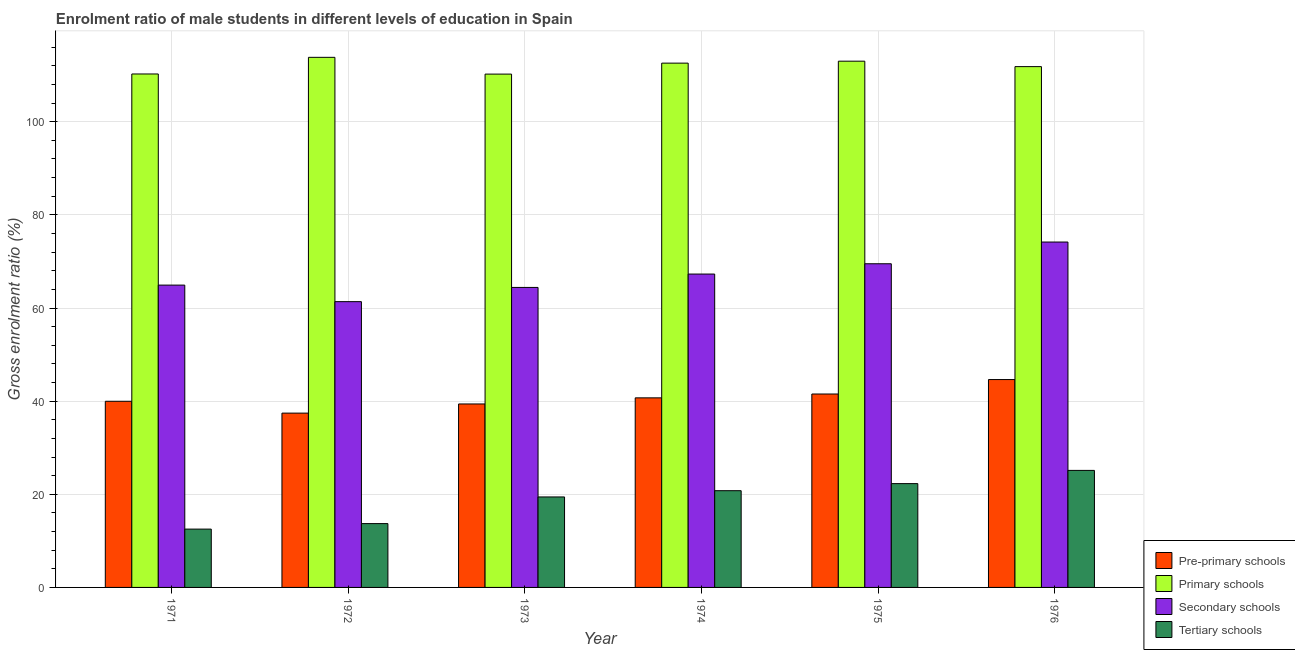How many groups of bars are there?
Offer a terse response. 6. Are the number of bars on each tick of the X-axis equal?
Your response must be concise. Yes. How many bars are there on the 3rd tick from the left?
Keep it short and to the point. 4. What is the label of the 6th group of bars from the left?
Provide a succinct answer. 1976. In how many cases, is the number of bars for a given year not equal to the number of legend labels?
Make the answer very short. 0. What is the gross enrolment ratio(female) in pre-primary schools in 1976?
Provide a short and direct response. 44.63. Across all years, what is the maximum gross enrolment ratio(female) in primary schools?
Your response must be concise. 113.83. Across all years, what is the minimum gross enrolment ratio(female) in pre-primary schools?
Your answer should be very brief. 37.43. What is the total gross enrolment ratio(female) in secondary schools in the graph?
Offer a very short reply. 401.65. What is the difference between the gross enrolment ratio(female) in pre-primary schools in 1972 and that in 1973?
Offer a terse response. -1.96. What is the difference between the gross enrolment ratio(female) in secondary schools in 1972 and the gross enrolment ratio(female) in primary schools in 1973?
Ensure brevity in your answer.  -3.05. What is the average gross enrolment ratio(female) in secondary schools per year?
Keep it short and to the point. 66.94. In how many years, is the gross enrolment ratio(female) in primary schools greater than 96 %?
Your answer should be very brief. 6. What is the ratio of the gross enrolment ratio(female) in pre-primary schools in 1971 to that in 1976?
Give a very brief answer. 0.9. Is the gross enrolment ratio(female) in secondary schools in 1974 less than that in 1975?
Offer a terse response. Yes. What is the difference between the highest and the second highest gross enrolment ratio(female) in pre-primary schools?
Ensure brevity in your answer.  3.1. What is the difference between the highest and the lowest gross enrolment ratio(female) in secondary schools?
Make the answer very short. 12.8. Is it the case that in every year, the sum of the gross enrolment ratio(female) in primary schools and gross enrolment ratio(female) in pre-primary schools is greater than the sum of gross enrolment ratio(female) in tertiary schools and gross enrolment ratio(female) in secondary schools?
Keep it short and to the point. Yes. What does the 3rd bar from the left in 1975 represents?
Your response must be concise. Secondary schools. What does the 3rd bar from the right in 1972 represents?
Offer a very short reply. Primary schools. Is it the case that in every year, the sum of the gross enrolment ratio(female) in pre-primary schools and gross enrolment ratio(female) in primary schools is greater than the gross enrolment ratio(female) in secondary schools?
Offer a very short reply. Yes. How many years are there in the graph?
Ensure brevity in your answer.  6. What is the difference between two consecutive major ticks on the Y-axis?
Provide a short and direct response. 20. Does the graph contain grids?
Make the answer very short. Yes. Where does the legend appear in the graph?
Offer a very short reply. Bottom right. How many legend labels are there?
Your answer should be compact. 4. How are the legend labels stacked?
Offer a terse response. Vertical. What is the title of the graph?
Provide a succinct answer. Enrolment ratio of male students in different levels of education in Spain. What is the label or title of the X-axis?
Give a very brief answer. Year. What is the label or title of the Y-axis?
Your answer should be compact. Gross enrolment ratio (%). What is the Gross enrolment ratio (%) of Pre-primary schools in 1971?
Your response must be concise. 39.97. What is the Gross enrolment ratio (%) of Primary schools in 1971?
Offer a very short reply. 110.25. What is the Gross enrolment ratio (%) in Secondary schools in 1971?
Your response must be concise. 64.92. What is the Gross enrolment ratio (%) of Tertiary schools in 1971?
Provide a succinct answer. 12.52. What is the Gross enrolment ratio (%) of Pre-primary schools in 1972?
Your answer should be compact. 37.43. What is the Gross enrolment ratio (%) in Primary schools in 1972?
Ensure brevity in your answer.  113.83. What is the Gross enrolment ratio (%) of Secondary schools in 1972?
Your answer should be very brief. 61.36. What is the Gross enrolment ratio (%) in Tertiary schools in 1972?
Offer a terse response. 13.71. What is the Gross enrolment ratio (%) in Pre-primary schools in 1973?
Give a very brief answer. 39.39. What is the Gross enrolment ratio (%) of Primary schools in 1973?
Provide a short and direct response. 110.23. What is the Gross enrolment ratio (%) in Secondary schools in 1973?
Provide a short and direct response. 64.42. What is the Gross enrolment ratio (%) of Tertiary schools in 1973?
Your answer should be very brief. 19.43. What is the Gross enrolment ratio (%) in Pre-primary schools in 1974?
Provide a short and direct response. 40.71. What is the Gross enrolment ratio (%) of Primary schools in 1974?
Your answer should be very brief. 112.58. What is the Gross enrolment ratio (%) of Secondary schools in 1974?
Ensure brevity in your answer.  67.29. What is the Gross enrolment ratio (%) of Tertiary schools in 1974?
Make the answer very short. 20.77. What is the Gross enrolment ratio (%) of Pre-primary schools in 1975?
Offer a very short reply. 41.53. What is the Gross enrolment ratio (%) of Primary schools in 1975?
Offer a very short reply. 113. What is the Gross enrolment ratio (%) in Secondary schools in 1975?
Ensure brevity in your answer.  69.5. What is the Gross enrolment ratio (%) of Tertiary schools in 1975?
Provide a succinct answer. 22.29. What is the Gross enrolment ratio (%) of Pre-primary schools in 1976?
Keep it short and to the point. 44.63. What is the Gross enrolment ratio (%) in Primary schools in 1976?
Provide a short and direct response. 111.83. What is the Gross enrolment ratio (%) of Secondary schools in 1976?
Provide a short and direct response. 74.17. What is the Gross enrolment ratio (%) in Tertiary schools in 1976?
Keep it short and to the point. 25.13. Across all years, what is the maximum Gross enrolment ratio (%) in Pre-primary schools?
Offer a very short reply. 44.63. Across all years, what is the maximum Gross enrolment ratio (%) in Primary schools?
Your response must be concise. 113.83. Across all years, what is the maximum Gross enrolment ratio (%) in Secondary schools?
Keep it short and to the point. 74.17. Across all years, what is the maximum Gross enrolment ratio (%) in Tertiary schools?
Offer a very short reply. 25.13. Across all years, what is the minimum Gross enrolment ratio (%) of Pre-primary schools?
Give a very brief answer. 37.43. Across all years, what is the minimum Gross enrolment ratio (%) of Primary schools?
Your answer should be very brief. 110.23. Across all years, what is the minimum Gross enrolment ratio (%) in Secondary schools?
Provide a succinct answer. 61.36. Across all years, what is the minimum Gross enrolment ratio (%) of Tertiary schools?
Provide a succinct answer. 12.52. What is the total Gross enrolment ratio (%) of Pre-primary schools in the graph?
Ensure brevity in your answer.  243.67. What is the total Gross enrolment ratio (%) of Primary schools in the graph?
Keep it short and to the point. 671.71. What is the total Gross enrolment ratio (%) in Secondary schools in the graph?
Your answer should be compact. 401.65. What is the total Gross enrolment ratio (%) of Tertiary schools in the graph?
Make the answer very short. 113.85. What is the difference between the Gross enrolment ratio (%) in Pre-primary schools in 1971 and that in 1972?
Offer a very short reply. 2.54. What is the difference between the Gross enrolment ratio (%) in Primary schools in 1971 and that in 1972?
Your answer should be compact. -3.58. What is the difference between the Gross enrolment ratio (%) in Secondary schools in 1971 and that in 1972?
Your answer should be compact. 3.55. What is the difference between the Gross enrolment ratio (%) in Tertiary schools in 1971 and that in 1972?
Provide a succinct answer. -1.18. What is the difference between the Gross enrolment ratio (%) in Pre-primary schools in 1971 and that in 1973?
Ensure brevity in your answer.  0.58. What is the difference between the Gross enrolment ratio (%) of Primary schools in 1971 and that in 1973?
Your answer should be compact. 0.03. What is the difference between the Gross enrolment ratio (%) in Secondary schools in 1971 and that in 1973?
Provide a short and direct response. 0.5. What is the difference between the Gross enrolment ratio (%) of Tertiary schools in 1971 and that in 1973?
Your answer should be very brief. -6.91. What is the difference between the Gross enrolment ratio (%) of Pre-primary schools in 1971 and that in 1974?
Offer a very short reply. -0.73. What is the difference between the Gross enrolment ratio (%) in Primary schools in 1971 and that in 1974?
Offer a very short reply. -2.33. What is the difference between the Gross enrolment ratio (%) in Secondary schools in 1971 and that in 1974?
Your answer should be very brief. -2.37. What is the difference between the Gross enrolment ratio (%) of Tertiary schools in 1971 and that in 1974?
Give a very brief answer. -8.25. What is the difference between the Gross enrolment ratio (%) in Pre-primary schools in 1971 and that in 1975?
Your answer should be compact. -1.56. What is the difference between the Gross enrolment ratio (%) in Primary schools in 1971 and that in 1975?
Your answer should be very brief. -2.75. What is the difference between the Gross enrolment ratio (%) of Secondary schools in 1971 and that in 1975?
Offer a very short reply. -4.58. What is the difference between the Gross enrolment ratio (%) in Tertiary schools in 1971 and that in 1975?
Your answer should be compact. -9.77. What is the difference between the Gross enrolment ratio (%) in Pre-primary schools in 1971 and that in 1976?
Offer a terse response. -4.66. What is the difference between the Gross enrolment ratio (%) of Primary schools in 1971 and that in 1976?
Your response must be concise. -1.58. What is the difference between the Gross enrolment ratio (%) of Secondary schools in 1971 and that in 1976?
Your answer should be compact. -9.25. What is the difference between the Gross enrolment ratio (%) of Tertiary schools in 1971 and that in 1976?
Keep it short and to the point. -12.61. What is the difference between the Gross enrolment ratio (%) in Pre-primary schools in 1972 and that in 1973?
Provide a short and direct response. -1.96. What is the difference between the Gross enrolment ratio (%) in Primary schools in 1972 and that in 1973?
Your response must be concise. 3.6. What is the difference between the Gross enrolment ratio (%) in Secondary schools in 1972 and that in 1973?
Give a very brief answer. -3.05. What is the difference between the Gross enrolment ratio (%) of Tertiary schools in 1972 and that in 1973?
Make the answer very short. -5.72. What is the difference between the Gross enrolment ratio (%) of Pre-primary schools in 1972 and that in 1974?
Your answer should be very brief. -3.28. What is the difference between the Gross enrolment ratio (%) of Primary schools in 1972 and that in 1974?
Provide a short and direct response. 1.25. What is the difference between the Gross enrolment ratio (%) in Secondary schools in 1972 and that in 1974?
Your response must be concise. -5.93. What is the difference between the Gross enrolment ratio (%) of Tertiary schools in 1972 and that in 1974?
Provide a short and direct response. -7.06. What is the difference between the Gross enrolment ratio (%) in Pre-primary schools in 1972 and that in 1975?
Keep it short and to the point. -4.1. What is the difference between the Gross enrolment ratio (%) in Primary schools in 1972 and that in 1975?
Ensure brevity in your answer.  0.83. What is the difference between the Gross enrolment ratio (%) of Secondary schools in 1972 and that in 1975?
Ensure brevity in your answer.  -8.13. What is the difference between the Gross enrolment ratio (%) of Tertiary schools in 1972 and that in 1975?
Your answer should be very brief. -8.58. What is the difference between the Gross enrolment ratio (%) of Pre-primary schools in 1972 and that in 1976?
Make the answer very short. -7.2. What is the difference between the Gross enrolment ratio (%) in Primary schools in 1972 and that in 1976?
Keep it short and to the point. 2. What is the difference between the Gross enrolment ratio (%) of Secondary schools in 1972 and that in 1976?
Give a very brief answer. -12.8. What is the difference between the Gross enrolment ratio (%) of Tertiary schools in 1972 and that in 1976?
Your answer should be very brief. -11.42. What is the difference between the Gross enrolment ratio (%) in Pre-primary schools in 1973 and that in 1974?
Keep it short and to the point. -1.31. What is the difference between the Gross enrolment ratio (%) of Primary schools in 1973 and that in 1974?
Provide a short and direct response. -2.35. What is the difference between the Gross enrolment ratio (%) in Secondary schools in 1973 and that in 1974?
Ensure brevity in your answer.  -2.87. What is the difference between the Gross enrolment ratio (%) of Tertiary schools in 1973 and that in 1974?
Ensure brevity in your answer.  -1.34. What is the difference between the Gross enrolment ratio (%) of Pre-primary schools in 1973 and that in 1975?
Keep it short and to the point. -2.14. What is the difference between the Gross enrolment ratio (%) in Primary schools in 1973 and that in 1975?
Your response must be concise. -2.77. What is the difference between the Gross enrolment ratio (%) of Secondary schools in 1973 and that in 1975?
Ensure brevity in your answer.  -5.08. What is the difference between the Gross enrolment ratio (%) of Tertiary schools in 1973 and that in 1975?
Offer a very short reply. -2.86. What is the difference between the Gross enrolment ratio (%) of Pre-primary schools in 1973 and that in 1976?
Your answer should be compact. -5.24. What is the difference between the Gross enrolment ratio (%) of Primary schools in 1973 and that in 1976?
Your answer should be very brief. -1.6. What is the difference between the Gross enrolment ratio (%) of Secondary schools in 1973 and that in 1976?
Your answer should be compact. -9.75. What is the difference between the Gross enrolment ratio (%) of Tertiary schools in 1973 and that in 1976?
Give a very brief answer. -5.7. What is the difference between the Gross enrolment ratio (%) of Pre-primary schools in 1974 and that in 1975?
Offer a very short reply. -0.82. What is the difference between the Gross enrolment ratio (%) in Primary schools in 1974 and that in 1975?
Provide a succinct answer. -0.42. What is the difference between the Gross enrolment ratio (%) of Secondary schools in 1974 and that in 1975?
Provide a short and direct response. -2.21. What is the difference between the Gross enrolment ratio (%) in Tertiary schools in 1974 and that in 1975?
Ensure brevity in your answer.  -1.52. What is the difference between the Gross enrolment ratio (%) in Pre-primary schools in 1974 and that in 1976?
Ensure brevity in your answer.  -3.93. What is the difference between the Gross enrolment ratio (%) in Primary schools in 1974 and that in 1976?
Your response must be concise. 0.75. What is the difference between the Gross enrolment ratio (%) of Secondary schools in 1974 and that in 1976?
Provide a short and direct response. -6.87. What is the difference between the Gross enrolment ratio (%) in Tertiary schools in 1974 and that in 1976?
Offer a very short reply. -4.36. What is the difference between the Gross enrolment ratio (%) of Pre-primary schools in 1975 and that in 1976?
Offer a very short reply. -3.1. What is the difference between the Gross enrolment ratio (%) of Primary schools in 1975 and that in 1976?
Make the answer very short. 1.17. What is the difference between the Gross enrolment ratio (%) of Secondary schools in 1975 and that in 1976?
Make the answer very short. -4.67. What is the difference between the Gross enrolment ratio (%) in Tertiary schools in 1975 and that in 1976?
Give a very brief answer. -2.84. What is the difference between the Gross enrolment ratio (%) in Pre-primary schools in 1971 and the Gross enrolment ratio (%) in Primary schools in 1972?
Provide a succinct answer. -73.85. What is the difference between the Gross enrolment ratio (%) of Pre-primary schools in 1971 and the Gross enrolment ratio (%) of Secondary schools in 1972?
Give a very brief answer. -21.39. What is the difference between the Gross enrolment ratio (%) in Pre-primary schools in 1971 and the Gross enrolment ratio (%) in Tertiary schools in 1972?
Ensure brevity in your answer.  26.27. What is the difference between the Gross enrolment ratio (%) in Primary schools in 1971 and the Gross enrolment ratio (%) in Secondary schools in 1972?
Give a very brief answer. 48.89. What is the difference between the Gross enrolment ratio (%) of Primary schools in 1971 and the Gross enrolment ratio (%) of Tertiary schools in 1972?
Offer a terse response. 96.54. What is the difference between the Gross enrolment ratio (%) of Secondary schools in 1971 and the Gross enrolment ratio (%) of Tertiary schools in 1972?
Your answer should be compact. 51.21. What is the difference between the Gross enrolment ratio (%) of Pre-primary schools in 1971 and the Gross enrolment ratio (%) of Primary schools in 1973?
Your answer should be compact. -70.25. What is the difference between the Gross enrolment ratio (%) in Pre-primary schools in 1971 and the Gross enrolment ratio (%) in Secondary schools in 1973?
Provide a succinct answer. -24.45. What is the difference between the Gross enrolment ratio (%) of Pre-primary schools in 1971 and the Gross enrolment ratio (%) of Tertiary schools in 1973?
Provide a succinct answer. 20.54. What is the difference between the Gross enrolment ratio (%) of Primary schools in 1971 and the Gross enrolment ratio (%) of Secondary schools in 1973?
Your response must be concise. 45.83. What is the difference between the Gross enrolment ratio (%) in Primary schools in 1971 and the Gross enrolment ratio (%) in Tertiary schools in 1973?
Make the answer very short. 90.82. What is the difference between the Gross enrolment ratio (%) in Secondary schools in 1971 and the Gross enrolment ratio (%) in Tertiary schools in 1973?
Offer a terse response. 45.49. What is the difference between the Gross enrolment ratio (%) of Pre-primary schools in 1971 and the Gross enrolment ratio (%) of Primary schools in 1974?
Provide a short and direct response. -72.61. What is the difference between the Gross enrolment ratio (%) in Pre-primary schools in 1971 and the Gross enrolment ratio (%) in Secondary schools in 1974?
Offer a very short reply. -27.32. What is the difference between the Gross enrolment ratio (%) of Pre-primary schools in 1971 and the Gross enrolment ratio (%) of Tertiary schools in 1974?
Keep it short and to the point. 19.2. What is the difference between the Gross enrolment ratio (%) of Primary schools in 1971 and the Gross enrolment ratio (%) of Secondary schools in 1974?
Your answer should be compact. 42.96. What is the difference between the Gross enrolment ratio (%) of Primary schools in 1971 and the Gross enrolment ratio (%) of Tertiary schools in 1974?
Keep it short and to the point. 89.48. What is the difference between the Gross enrolment ratio (%) of Secondary schools in 1971 and the Gross enrolment ratio (%) of Tertiary schools in 1974?
Give a very brief answer. 44.15. What is the difference between the Gross enrolment ratio (%) in Pre-primary schools in 1971 and the Gross enrolment ratio (%) in Primary schools in 1975?
Ensure brevity in your answer.  -73.03. What is the difference between the Gross enrolment ratio (%) of Pre-primary schools in 1971 and the Gross enrolment ratio (%) of Secondary schools in 1975?
Provide a short and direct response. -29.53. What is the difference between the Gross enrolment ratio (%) in Pre-primary schools in 1971 and the Gross enrolment ratio (%) in Tertiary schools in 1975?
Your response must be concise. 17.68. What is the difference between the Gross enrolment ratio (%) in Primary schools in 1971 and the Gross enrolment ratio (%) in Secondary schools in 1975?
Make the answer very short. 40.75. What is the difference between the Gross enrolment ratio (%) in Primary schools in 1971 and the Gross enrolment ratio (%) in Tertiary schools in 1975?
Provide a short and direct response. 87.96. What is the difference between the Gross enrolment ratio (%) of Secondary schools in 1971 and the Gross enrolment ratio (%) of Tertiary schools in 1975?
Give a very brief answer. 42.63. What is the difference between the Gross enrolment ratio (%) in Pre-primary schools in 1971 and the Gross enrolment ratio (%) in Primary schools in 1976?
Make the answer very short. -71.86. What is the difference between the Gross enrolment ratio (%) of Pre-primary schools in 1971 and the Gross enrolment ratio (%) of Secondary schools in 1976?
Offer a terse response. -34.19. What is the difference between the Gross enrolment ratio (%) in Pre-primary schools in 1971 and the Gross enrolment ratio (%) in Tertiary schools in 1976?
Your answer should be very brief. 14.84. What is the difference between the Gross enrolment ratio (%) of Primary schools in 1971 and the Gross enrolment ratio (%) of Secondary schools in 1976?
Your response must be concise. 36.09. What is the difference between the Gross enrolment ratio (%) in Primary schools in 1971 and the Gross enrolment ratio (%) in Tertiary schools in 1976?
Your response must be concise. 85.12. What is the difference between the Gross enrolment ratio (%) of Secondary schools in 1971 and the Gross enrolment ratio (%) of Tertiary schools in 1976?
Your response must be concise. 39.79. What is the difference between the Gross enrolment ratio (%) of Pre-primary schools in 1972 and the Gross enrolment ratio (%) of Primary schools in 1973?
Provide a short and direct response. -72.8. What is the difference between the Gross enrolment ratio (%) of Pre-primary schools in 1972 and the Gross enrolment ratio (%) of Secondary schools in 1973?
Offer a very short reply. -26.99. What is the difference between the Gross enrolment ratio (%) in Pre-primary schools in 1972 and the Gross enrolment ratio (%) in Tertiary schools in 1973?
Ensure brevity in your answer.  18. What is the difference between the Gross enrolment ratio (%) in Primary schools in 1972 and the Gross enrolment ratio (%) in Secondary schools in 1973?
Make the answer very short. 49.41. What is the difference between the Gross enrolment ratio (%) in Primary schools in 1972 and the Gross enrolment ratio (%) in Tertiary schools in 1973?
Your response must be concise. 94.4. What is the difference between the Gross enrolment ratio (%) of Secondary schools in 1972 and the Gross enrolment ratio (%) of Tertiary schools in 1973?
Your answer should be compact. 41.93. What is the difference between the Gross enrolment ratio (%) in Pre-primary schools in 1972 and the Gross enrolment ratio (%) in Primary schools in 1974?
Offer a very short reply. -75.15. What is the difference between the Gross enrolment ratio (%) in Pre-primary schools in 1972 and the Gross enrolment ratio (%) in Secondary schools in 1974?
Offer a terse response. -29.86. What is the difference between the Gross enrolment ratio (%) of Pre-primary schools in 1972 and the Gross enrolment ratio (%) of Tertiary schools in 1974?
Your response must be concise. 16.66. What is the difference between the Gross enrolment ratio (%) in Primary schools in 1972 and the Gross enrolment ratio (%) in Secondary schools in 1974?
Ensure brevity in your answer.  46.54. What is the difference between the Gross enrolment ratio (%) in Primary schools in 1972 and the Gross enrolment ratio (%) in Tertiary schools in 1974?
Provide a short and direct response. 93.06. What is the difference between the Gross enrolment ratio (%) of Secondary schools in 1972 and the Gross enrolment ratio (%) of Tertiary schools in 1974?
Ensure brevity in your answer.  40.59. What is the difference between the Gross enrolment ratio (%) of Pre-primary schools in 1972 and the Gross enrolment ratio (%) of Primary schools in 1975?
Ensure brevity in your answer.  -75.57. What is the difference between the Gross enrolment ratio (%) of Pre-primary schools in 1972 and the Gross enrolment ratio (%) of Secondary schools in 1975?
Offer a very short reply. -32.07. What is the difference between the Gross enrolment ratio (%) of Pre-primary schools in 1972 and the Gross enrolment ratio (%) of Tertiary schools in 1975?
Your answer should be compact. 15.14. What is the difference between the Gross enrolment ratio (%) in Primary schools in 1972 and the Gross enrolment ratio (%) in Secondary schools in 1975?
Your answer should be compact. 44.33. What is the difference between the Gross enrolment ratio (%) of Primary schools in 1972 and the Gross enrolment ratio (%) of Tertiary schools in 1975?
Your answer should be very brief. 91.54. What is the difference between the Gross enrolment ratio (%) of Secondary schools in 1972 and the Gross enrolment ratio (%) of Tertiary schools in 1975?
Offer a very short reply. 39.08. What is the difference between the Gross enrolment ratio (%) in Pre-primary schools in 1972 and the Gross enrolment ratio (%) in Primary schools in 1976?
Keep it short and to the point. -74.4. What is the difference between the Gross enrolment ratio (%) of Pre-primary schools in 1972 and the Gross enrolment ratio (%) of Secondary schools in 1976?
Offer a very short reply. -36.74. What is the difference between the Gross enrolment ratio (%) of Pre-primary schools in 1972 and the Gross enrolment ratio (%) of Tertiary schools in 1976?
Offer a very short reply. 12.3. What is the difference between the Gross enrolment ratio (%) in Primary schools in 1972 and the Gross enrolment ratio (%) in Secondary schools in 1976?
Provide a short and direct response. 39.66. What is the difference between the Gross enrolment ratio (%) in Primary schools in 1972 and the Gross enrolment ratio (%) in Tertiary schools in 1976?
Your answer should be compact. 88.7. What is the difference between the Gross enrolment ratio (%) in Secondary schools in 1972 and the Gross enrolment ratio (%) in Tertiary schools in 1976?
Your answer should be compact. 36.24. What is the difference between the Gross enrolment ratio (%) of Pre-primary schools in 1973 and the Gross enrolment ratio (%) of Primary schools in 1974?
Give a very brief answer. -73.18. What is the difference between the Gross enrolment ratio (%) of Pre-primary schools in 1973 and the Gross enrolment ratio (%) of Secondary schools in 1974?
Ensure brevity in your answer.  -27.9. What is the difference between the Gross enrolment ratio (%) of Pre-primary schools in 1973 and the Gross enrolment ratio (%) of Tertiary schools in 1974?
Give a very brief answer. 18.62. What is the difference between the Gross enrolment ratio (%) of Primary schools in 1973 and the Gross enrolment ratio (%) of Secondary schools in 1974?
Your answer should be compact. 42.94. What is the difference between the Gross enrolment ratio (%) of Primary schools in 1973 and the Gross enrolment ratio (%) of Tertiary schools in 1974?
Ensure brevity in your answer.  89.45. What is the difference between the Gross enrolment ratio (%) in Secondary schools in 1973 and the Gross enrolment ratio (%) in Tertiary schools in 1974?
Provide a succinct answer. 43.65. What is the difference between the Gross enrolment ratio (%) in Pre-primary schools in 1973 and the Gross enrolment ratio (%) in Primary schools in 1975?
Provide a short and direct response. -73.61. What is the difference between the Gross enrolment ratio (%) of Pre-primary schools in 1973 and the Gross enrolment ratio (%) of Secondary schools in 1975?
Offer a terse response. -30.1. What is the difference between the Gross enrolment ratio (%) of Pre-primary schools in 1973 and the Gross enrolment ratio (%) of Tertiary schools in 1975?
Offer a very short reply. 17.11. What is the difference between the Gross enrolment ratio (%) in Primary schools in 1973 and the Gross enrolment ratio (%) in Secondary schools in 1975?
Offer a terse response. 40.73. What is the difference between the Gross enrolment ratio (%) of Primary schools in 1973 and the Gross enrolment ratio (%) of Tertiary schools in 1975?
Provide a succinct answer. 87.94. What is the difference between the Gross enrolment ratio (%) of Secondary schools in 1973 and the Gross enrolment ratio (%) of Tertiary schools in 1975?
Make the answer very short. 42.13. What is the difference between the Gross enrolment ratio (%) in Pre-primary schools in 1973 and the Gross enrolment ratio (%) in Primary schools in 1976?
Provide a succinct answer. -72.44. What is the difference between the Gross enrolment ratio (%) of Pre-primary schools in 1973 and the Gross enrolment ratio (%) of Secondary schools in 1976?
Give a very brief answer. -34.77. What is the difference between the Gross enrolment ratio (%) in Pre-primary schools in 1973 and the Gross enrolment ratio (%) in Tertiary schools in 1976?
Your answer should be compact. 14.27. What is the difference between the Gross enrolment ratio (%) of Primary schools in 1973 and the Gross enrolment ratio (%) of Secondary schools in 1976?
Keep it short and to the point. 36.06. What is the difference between the Gross enrolment ratio (%) of Primary schools in 1973 and the Gross enrolment ratio (%) of Tertiary schools in 1976?
Your response must be concise. 85.1. What is the difference between the Gross enrolment ratio (%) in Secondary schools in 1973 and the Gross enrolment ratio (%) in Tertiary schools in 1976?
Make the answer very short. 39.29. What is the difference between the Gross enrolment ratio (%) of Pre-primary schools in 1974 and the Gross enrolment ratio (%) of Primary schools in 1975?
Give a very brief answer. -72.29. What is the difference between the Gross enrolment ratio (%) of Pre-primary schools in 1974 and the Gross enrolment ratio (%) of Secondary schools in 1975?
Offer a very short reply. -28.79. What is the difference between the Gross enrolment ratio (%) in Pre-primary schools in 1974 and the Gross enrolment ratio (%) in Tertiary schools in 1975?
Offer a terse response. 18.42. What is the difference between the Gross enrolment ratio (%) of Primary schools in 1974 and the Gross enrolment ratio (%) of Secondary schools in 1975?
Make the answer very short. 43.08. What is the difference between the Gross enrolment ratio (%) in Primary schools in 1974 and the Gross enrolment ratio (%) in Tertiary schools in 1975?
Your answer should be compact. 90.29. What is the difference between the Gross enrolment ratio (%) in Secondary schools in 1974 and the Gross enrolment ratio (%) in Tertiary schools in 1975?
Your answer should be compact. 45. What is the difference between the Gross enrolment ratio (%) in Pre-primary schools in 1974 and the Gross enrolment ratio (%) in Primary schools in 1976?
Make the answer very short. -71.12. What is the difference between the Gross enrolment ratio (%) of Pre-primary schools in 1974 and the Gross enrolment ratio (%) of Secondary schools in 1976?
Provide a succinct answer. -33.46. What is the difference between the Gross enrolment ratio (%) of Pre-primary schools in 1974 and the Gross enrolment ratio (%) of Tertiary schools in 1976?
Make the answer very short. 15.58. What is the difference between the Gross enrolment ratio (%) in Primary schools in 1974 and the Gross enrolment ratio (%) in Secondary schools in 1976?
Your answer should be very brief. 38.41. What is the difference between the Gross enrolment ratio (%) in Primary schools in 1974 and the Gross enrolment ratio (%) in Tertiary schools in 1976?
Give a very brief answer. 87.45. What is the difference between the Gross enrolment ratio (%) of Secondary schools in 1974 and the Gross enrolment ratio (%) of Tertiary schools in 1976?
Keep it short and to the point. 42.16. What is the difference between the Gross enrolment ratio (%) in Pre-primary schools in 1975 and the Gross enrolment ratio (%) in Primary schools in 1976?
Keep it short and to the point. -70.3. What is the difference between the Gross enrolment ratio (%) of Pre-primary schools in 1975 and the Gross enrolment ratio (%) of Secondary schools in 1976?
Provide a short and direct response. -32.63. What is the difference between the Gross enrolment ratio (%) of Pre-primary schools in 1975 and the Gross enrolment ratio (%) of Tertiary schools in 1976?
Make the answer very short. 16.4. What is the difference between the Gross enrolment ratio (%) in Primary schools in 1975 and the Gross enrolment ratio (%) in Secondary schools in 1976?
Your response must be concise. 38.83. What is the difference between the Gross enrolment ratio (%) in Primary schools in 1975 and the Gross enrolment ratio (%) in Tertiary schools in 1976?
Ensure brevity in your answer.  87.87. What is the difference between the Gross enrolment ratio (%) in Secondary schools in 1975 and the Gross enrolment ratio (%) in Tertiary schools in 1976?
Provide a succinct answer. 44.37. What is the average Gross enrolment ratio (%) of Pre-primary schools per year?
Give a very brief answer. 40.61. What is the average Gross enrolment ratio (%) in Primary schools per year?
Your response must be concise. 111.95. What is the average Gross enrolment ratio (%) in Secondary schools per year?
Make the answer very short. 66.94. What is the average Gross enrolment ratio (%) in Tertiary schools per year?
Your answer should be very brief. 18.97. In the year 1971, what is the difference between the Gross enrolment ratio (%) in Pre-primary schools and Gross enrolment ratio (%) in Primary schools?
Provide a succinct answer. -70.28. In the year 1971, what is the difference between the Gross enrolment ratio (%) of Pre-primary schools and Gross enrolment ratio (%) of Secondary schools?
Your response must be concise. -24.94. In the year 1971, what is the difference between the Gross enrolment ratio (%) in Pre-primary schools and Gross enrolment ratio (%) in Tertiary schools?
Offer a very short reply. 27.45. In the year 1971, what is the difference between the Gross enrolment ratio (%) in Primary schools and Gross enrolment ratio (%) in Secondary schools?
Provide a succinct answer. 45.33. In the year 1971, what is the difference between the Gross enrolment ratio (%) in Primary schools and Gross enrolment ratio (%) in Tertiary schools?
Provide a succinct answer. 97.73. In the year 1971, what is the difference between the Gross enrolment ratio (%) of Secondary schools and Gross enrolment ratio (%) of Tertiary schools?
Provide a short and direct response. 52.39. In the year 1972, what is the difference between the Gross enrolment ratio (%) in Pre-primary schools and Gross enrolment ratio (%) in Primary schools?
Provide a short and direct response. -76.4. In the year 1972, what is the difference between the Gross enrolment ratio (%) in Pre-primary schools and Gross enrolment ratio (%) in Secondary schools?
Provide a succinct answer. -23.93. In the year 1972, what is the difference between the Gross enrolment ratio (%) in Pre-primary schools and Gross enrolment ratio (%) in Tertiary schools?
Your answer should be very brief. 23.72. In the year 1972, what is the difference between the Gross enrolment ratio (%) in Primary schools and Gross enrolment ratio (%) in Secondary schools?
Make the answer very short. 52.46. In the year 1972, what is the difference between the Gross enrolment ratio (%) of Primary schools and Gross enrolment ratio (%) of Tertiary schools?
Make the answer very short. 100.12. In the year 1972, what is the difference between the Gross enrolment ratio (%) of Secondary schools and Gross enrolment ratio (%) of Tertiary schools?
Offer a terse response. 47.66. In the year 1973, what is the difference between the Gross enrolment ratio (%) of Pre-primary schools and Gross enrolment ratio (%) of Primary schools?
Your answer should be compact. -70.83. In the year 1973, what is the difference between the Gross enrolment ratio (%) of Pre-primary schools and Gross enrolment ratio (%) of Secondary schools?
Provide a short and direct response. -25.02. In the year 1973, what is the difference between the Gross enrolment ratio (%) of Pre-primary schools and Gross enrolment ratio (%) of Tertiary schools?
Give a very brief answer. 19.96. In the year 1973, what is the difference between the Gross enrolment ratio (%) of Primary schools and Gross enrolment ratio (%) of Secondary schools?
Make the answer very short. 45.81. In the year 1973, what is the difference between the Gross enrolment ratio (%) in Primary schools and Gross enrolment ratio (%) in Tertiary schools?
Your response must be concise. 90.8. In the year 1973, what is the difference between the Gross enrolment ratio (%) in Secondary schools and Gross enrolment ratio (%) in Tertiary schools?
Ensure brevity in your answer.  44.99. In the year 1974, what is the difference between the Gross enrolment ratio (%) in Pre-primary schools and Gross enrolment ratio (%) in Primary schools?
Your answer should be compact. -71.87. In the year 1974, what is the difference between the Gross enrolment ratio (%) in Pre-primary schools and Gross enrolment ratio (%) in Secondary schools?
Your answer should be very brief. -26.58. In the year 1974, what is the difference between the Gross enrolment ratio (%) in Pre-primary schools and Gross enrolment ratio (%) in Tertiary schools?
Your answer should be compact. 19.94. In the year 1974, what is the difference between the Gross enrolment ratio (%) in Primary schools and Gross enrolment ratio (%) in Secondary schools?
Make the answer very short. 45.29. In the year 1974, what is the difference between the Gross enrolment ratio (%) in Primary schools and Gross enrolment ratio (%) in Tertiary schools?
Offer a very short reply. 91.81. In the year 1974, what is the difference between the Gross enrolment ratio (%) in Secondary schools and Gross enrolment ratio (%) in Tertiary schools?
Offer a very short reply. 46.52. In the year 1975, what is the difference between the Gross enrolment ratio (%) of Pre-primary schools and Gross enrolment ratio (%) of Primary schools?
Provide a succinct answer. -71.47. In the year 1975, what is the difference between the Gross enrolment ratio (%) in Pre-primary schools and Gross enrolment ratio (%) in Secondary schools?
Give a very brief answer. -27.97. In the year 1975, what is the difference between the Gross enrolment ratio (%) of Pre-primary schools and Gross enrolment ratio (%) of Tertiary schools?
Provide a short and direct response. 19.24. In the year 1975, what is the difference between the Gross enrolment ratio (%) of Primary schools and Gross enrolment ratio (%) of Secondary schools?
Ensure brevity in your answer.  43.5. In the year 1975, what is the difference between the Gross enrolment ratio (%) of Primary schools and Gross enrolment ratio (%) of Tertiary schools?
Provide a succinct answer. 90.71. In the year 1975, what is the difference between the Gross enrolment ratio (%) of Secondary schools and Gross enrolment ratio (%) of Tertiary schools?
Your response must be concise. 47.21. In the year 1976, what is the difference between the Gross enrolment ratio (%) in Pre-primary schools and Gross enrolment ratio (%) in Primary schools?
Make the answer very short. -67.2. In the year 1976, what is the difference between the Gross enrolment ratio (%) in Pre-primary schools and Gross enrolment ratio (%) in Secondary schools?
Your response must be concise. -29.53. In the year 1976, what is the difference between the Gross enrolment ratio (%) of Pre-primary schools and Gross enrolment ratio (%) of Tertiary schools?
Your answer should be compact. 19.51. In the year 1976, what is the difference between the Gross enrolment ratio (%) in Primary schools and Gross enrolment ratio (%) in Secondary schools?
Provide a succinct answer. 37.66. In the year 1976, what is the difference between the Gross enrolment ratio (%) of Primary schools and Gross enrolment ratio (%) of Tertiary schools?
Offer a terse response. 86.7. In the year 1976, what is the difference between the Gross enrolment ratio (%) in Secondary schools and Gross enrolment ratio (%) in Tertiary schools?
Your answer should be very brief. 49.04. What is the ratio of the Gross enrolment ratio (%) of Pre-primary schools in 1971 to that in 1972?
Your response must be concise. 1.07. What is the ratio of the Gross enrolment ratio (%) in Primary schools in 1971 to that in 1972?
Provide a succinct answer. 0.97. What is the ratio of the Gross enrolment ratio (%) of Secondary schools in 1971 to that in 1972?
Keep it short and to the point. 1.06. What is the ratio of the Gross enrolment ratio (%) in Tertiary schools in 1971 to that in 1972?
Ensure brevity in your answer.  0.91. What is the ratio of the Gross enrolment ratio (%) in Pre-primary schools in 1971 to that in 1973?
Ensure brevity in your answer.  1.01. What is the ratio of the Gross enrolment ratio (%) in Secondary schools in 1971 to that in 1973?
Ensure brevity in your answer.  1.01. What is the ratio of the Gross enrolment ratio (%) of Tertiary schools in 1971 to that in 1973?
Your response must be concise. 0.64. What is the ratio of the Gross enrolment ratio (%) in Pre-primary schools in 1971 to that in 1974?
Your response must be concise. 0.98. What is the ratio of the Gross enrolment ratio (%) of Primary schools in 1971 to that in 1974?
Offer a very short reply. 0.98. What is the ratio of the Gross enrolment ratio (%) of Secondary schools in 1971 to that in 1974?
Keep it short and to the point. 0.96. What is the ratio of the Gross enrolment ratio (%) of Tertiary schools in 1971 to that in 1974?
Ensure brevity in your answer.  0.6. What is the ratio of the Gross enrolment ratio (%) of Pre-primary schools in 1971 to that in 1975?
Your answer should be very brief. 0.96. What is the ratio of the Gross enrolment ratio (%) in Primary schools in 1971 to that in 1975?
Your answer should be very brief. 0.98. What is the ratio of the Gross enrolment ratio (%) in Secondary schools in 1971 to that in 1975?
Make the answer very short. 0.93. What is the ratio of the Gross enrolment ratio (%) of Tertiary schools in 1971 to that in 1975?
Keep it short and to the point. 0.56. What is the ratio of the Gross enrolment ratio (%) in Pre-primary schools in 1971 to that in 1976?
Your answer should be compact. 0.9. What is the ratio of the Gross enrolment ratio (%) of Primary schools in 1971 to that in 1976?
Keep it short and to the point. 0.99. What is the ratio of the Gross enrolment ratio (%) of Secondary schools in 1971 to that in 1976?
Your answer should be compact. 0.88. What is the ratio of the Gross enrolment ratio (%) in Tertiary schools in 1971 to that in 1976?
Provide a succinct answer. 0.5. What is the ratio of the Gross enrolment ratio (%) in Pre-primary schools in 1972 to that in 1973?
Your response must be concise. 0.95. What is the ratio of the Gross enrolment ratio (%) in Primary schools in 1972 to that in 1973?
Give a very brief answer. 1.03. What is the ratio of the Gross enrolment ratio (%) in Secondary schools in 1972 to that in 1973?
Ensure brevity in your answer.  0.95. What is the ratio of the Gross enrolment ratio (%) in Tertiary schools in 1972 to that in 1973?
Your answer should be very brief. 0.71. What is the ratio of the Gross enrolment ratio (%) in Pre-primary schools in 1972 to that in 1974?
Offer a very short reply. 0.92. What is the ratio of the Gross enrolment ratio (%) in Primary schools in 1972 to that in 1974?
Give a very brief answer. 1.01. What is the ratio of the Gross enrolment ratio (%) of Secondary schools in 1972 to that in 1974?
Make the answer very short. 0.91. What is the ratio of the Gross enrolment ratio (%) in Tertiary schools in 1972 to that in 1974?
Offer a very short reply. 0.66. What is the ratio of the Gross enrolment ratio (%) in Pre-primary schools in 1972 to that in 1975?
Keep it short and to the point. 0.9. What is the ratio of the Gross enrolment ratio (%) in Primary schools in 1972 to that in 1975?
Keep it short and to the point. 1.01. What is the ratio of the Gross enrolment ratio (%) in Secondary schools in 1972 to that in 1975?
Your response must be concise. 0.88. What is the ratio of the Gross enrolment ratio (%) of Tertiary schools in 1972 to that in 1975?
Offer a terse response. 0.61. What is the ratio of the Gross enrolment ratio (%) in Pre-primary schools in 1972 to that in 1976?
Provide a short and direct response. 0.84. What is the ratio of the Gross enrolment ratio (%) of Primary schools in 1972 to that in 1976?
Ensure brevity in your answer.  1.02. What is the ratio of the Gross enrolment ratio (%) in Secondary schools in 1972 to that in 1976?
Your answer should be very brief. 0.83. What is the ratio of the Gross enrolment ratio (%) in Tertiary schools in 1972 to that in 1976?
Your answer should be compact. 0.55. What is the ratio of the Gross enrolment ratio (%) in Pre-primary schools in 1973 to that in 1974?
Give a very brief answer. 0.97. What is the ratio of the Gross enrolment ratio (%) of Primary schools in 1973 to that in 1974?
Provide a short and direct response. 0.98. What is the ratio of the Gross enrolment ratio (%) of Secondary schools in 1973 to that in 1974?
Offer a terse response. 0.96. What is the ratio of the Gross enrolment ratio (%) of Tertiary schools in 1973 to that in 1974?
Your response must be concise. 0.94. What is the ratio of the Gross enrolment ratio (%) of Pre-primary schools in 1973 to that in 1975?
Give a very brief answer. 0.95. What is the ratio of the Gross enrolment ratio (%) in Primary schools in 1973 to that in 1975?
Offer a terse response. 0.98. What is the ratio of the Gross enrolment ratio (%) of Secondary schools in 1973 to that in 1975?
Offer a very short reply. 0.93. What is the ratio of the Gross enrolment ratio (%) in Tertiary schools in 1973 to that in 1975?
Offer a terse response. 0.87. What is the ratio of the Gross enrolment ratio (%) in Pre-primary schools in 1973 to that in 1976?
Provide a short and direct response. 0.88. What is the ratio of the Gross enrolment ratio (%) in Primary schools in 1973 to that in 1976?
Give a very brief answer. 0.99. What is the ratio of the Gross enrolment ratio (%) of Secondary schools in 1973 to that in 1976?
Your answer should be very brief. 0.87. What is the ratio of the Gross enrolment ratio (%) in Tertiary schools in 1973 to that in 1976?
Your answer should be very brief. 0.77. What is the ratio of the Gross enrolment ratio (%) of Pre-primary schools in 1974 to that in 1975?
Give a very brief answer. 0.98. What is the ratio of the Gross enrolment ratio (%) of Secondary schools in 1974 to that in 1975?
Provide a short and direct response. 0.97. What is the ratio of the Gross enrolment ratio (%) of Tertiary schools in 1974 to that in 1975?
Ensure brevity in your answer.  0.93. What is the ratio of the Gross enrolment ratio (%) in Pre-primary schools in 1974 to that in 1976?
Ensure brevity in your answer.  0.91. What is the ratio of the Gross enrolment ratio (%) in Primary schools in 1974 to that in 1976?
Ensure brevity in your answer.  1.01. What is the ratio of the Gross enrolment ratio (%) of Secondary schools in 1974 to that in 1976?
Your response must be concise. 0.91. What is the ratio of the Gross enrolment ratio (%) of Tertiary schools in 1974 to that in 1976?
Keep it short and to the point. 0.83. What is the ratio of the Gross enrolment ratio (%) of Pre-primary schools in 1975 to that in 1976?
Provide a short and direct response. 0.93. What is the ratio of the Gross enrolment ratio (%) in Primary schools in 1975 to that in 1976?
Offer a very short reply. 1.01. What is the ratio of the Gross enrolment ratio (%) in Secondary schools in 1975 to that in 1976?
Give a very brief answer. 0.94. What is the ratio of the Gross enrolment ratio (%) of Tertiary schools in 1975 to that in 1976?
Provide a short and direct response. 0.89. What is the difference between the highest and the second highest Gross enrolment ratio (%) of Pre-primary schools?
Give a very brief answer. 3.1. What is the difference between the highest and the second highest Gross enrolment ratio (%) in Primary schools?
Provide a succinct answer. 0.83. What is the difference between the highest and the second highest Gross enrolment ratio (%) of Secondary schools?
Provide a succinct answer. 4.67. What is the difference between the highest and the second highest Gross enrolment ratio (%) in Tertiary schools?
Ensure brevity in your answer.  2.84. What is the difference between the highest and the lowest Gross enrolment ratio (%) in Pre-primary schools?
Your answer should be compact. 7.2. What is the difference between the highest and the lowest Gross enrolment ratio (%) of Primary schools?
Keep it short and to the point. 3.6. What is the difference between the highest and the lowest Gross enrolment ratio (%) in Secondary schools?
Give a very brief answer. 12.8. What is the difference between the highest and the lowest Gross enrolment ratio (%) in Tertiary schools?
Provide a succinct answer. 12.61. 